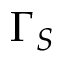<formula> <loc_0><loc_0><loc_500><loc_500>\Gamma _ { S }</formula> 